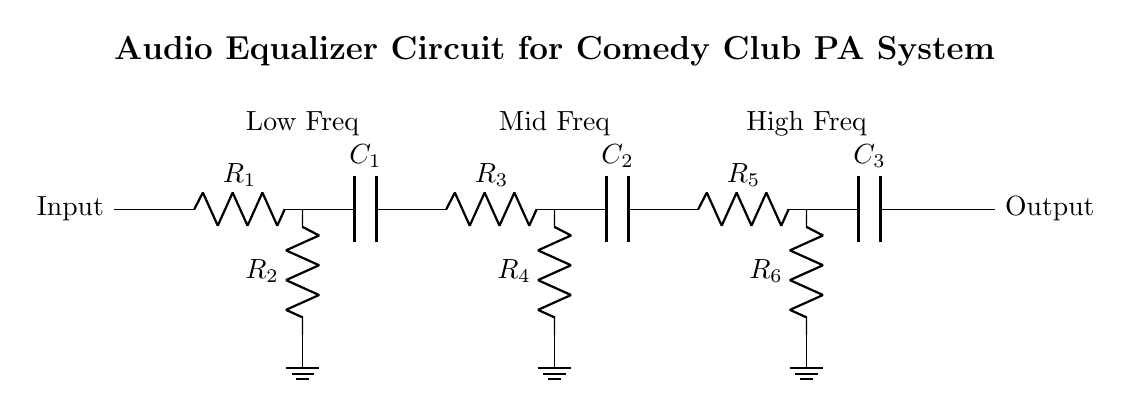What is the input of the circuit? The input component is labeled as "Input" on the left side of the circuit drawing, showing where the audio signal enters the equalizer.
Answer: Input How many resistors are in the circuit? Counting the resistors denoted by R, there are a total of six resistors labeled R1 through R6 in the circuit diagram.
Answer: Six Which stage handles low frequencies? The low frequency stage consists of components R1 and C1, which are specifically labeled and positioned as the first section of the circuit after the input.
Answer: Low Freq What is the role of capacitors in this circuit? Capacitors in this circuit (C1, C2, C3) are used to block DC voltage while allowing AC signals of certain frequencies to pass, working to filter specific frequency ranges.
Answer: Filtering frequencies What type of filter configuration is represented in this circuit? This circuit uses a band-pass filter configuration as it incorporates both resistors and capacitors across multiple stages to isolate specific frequency ranges (low, mid, high).
Answer: Band-pass filter What is the output of the circuit? The output is labeled as "Output" on the right side of the circuit diagram, indicating where the processed audio signal exits the equalizer.
Answer: Output 